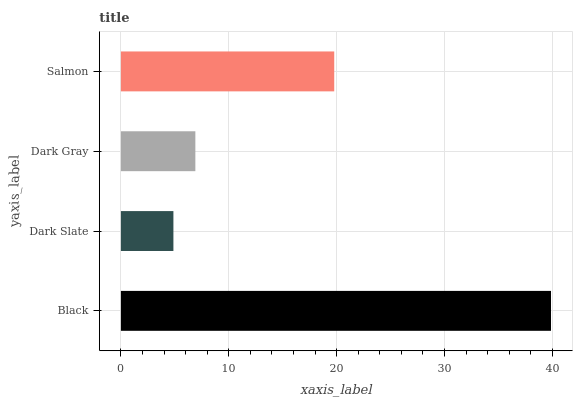Is Dark Slate the minimum?
Answer yes or no. Yes. Is Black the maximum?
Answer yes or no. Yes. Is Dark Gray the minimum?
Answer yes or no. No. Is Dark Gray the maximum?
Answer yes or no. No. Is Dark Gray greater than Dark Slate?
Answer yes or no. Yes. Is Dark Slate less than Dark Gray?
Answer yes or no. Yes. Is Dark Slate greater than Dark Gray?
Answer yes or no. No. Is Dark Gray less than Dark Slate?
Answer yes or no. No. Is Salmon the high median?
Answer yes or no. Yes. Is Dark Gray the low median?
Answer yes or no. Yes. Is Dark Slate the high median?
Answer yes or no. No. Is Salmon the low median?
Answer yes or no. No. 